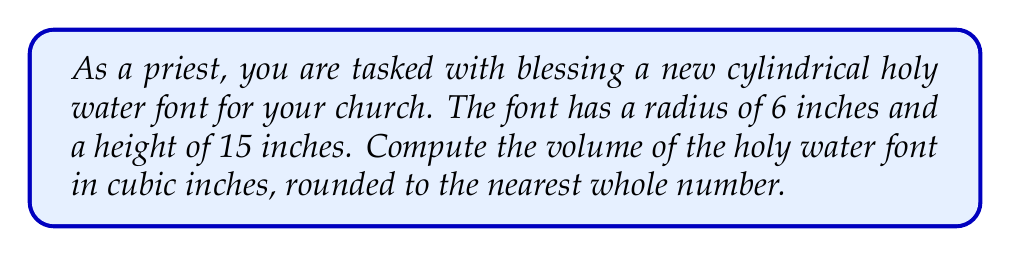Could you help me with this problem? To calculate the volume of a cylindrical holy water font, we use the formula for the volume of a cylinder:

$$V = \pi r^2 h$$

Where:
$V$ = volume
$r$ = radius of the base
$h$ = height of the cylinder

Given:
$r = 6$ inches
$h = 15$ inches

Let's substitute these values into the formula:

$$V = \pi (6 \text{ in})^2 (15 \text{ in})$$

Simplify:
$$V = \pi (36 \text{ in}^2) (15 \text{ in})$$
$$V = 540\pi \text{ in}^3$$

Now, let's calculate this value:
$$V \approx 540 \times 3.14159 \text{ in}^3$$
$$V \approx 1696.46 \text{ in}^3$$

Rounding to the nearest whole number:
$$V \approx 1696 \text{ in}^3$$

This volume represents the capacity of the holy water font, which will be used to hold the blessed water for the faithful.
Answer: The volume of the cylindrical holy water font is approximately 1696 cubic inches. 